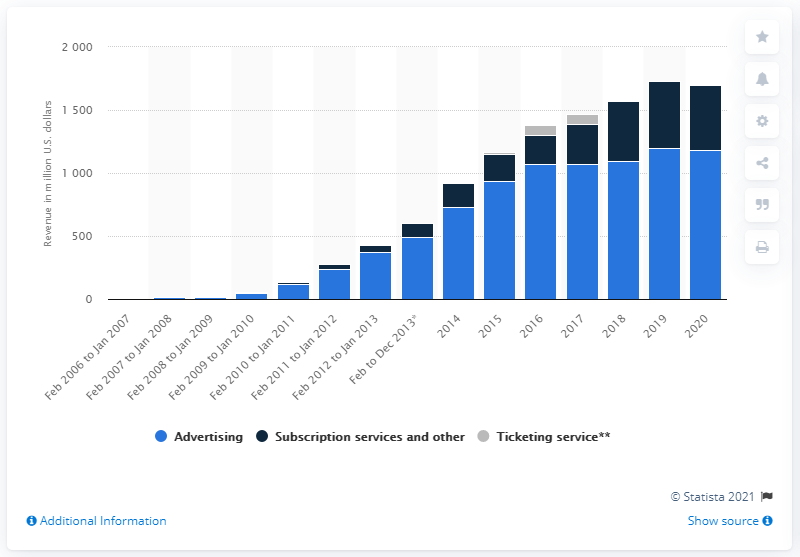Draw attention to some important aspects in this diagram. Pandora generated approximately 1,200 million dollars in advertising revenue in the fiscal year ending 2020. In 2020, Pandora's subscription revenue was approximately 515 million dollars. The fiscal year of Pandora ended in 2020. 